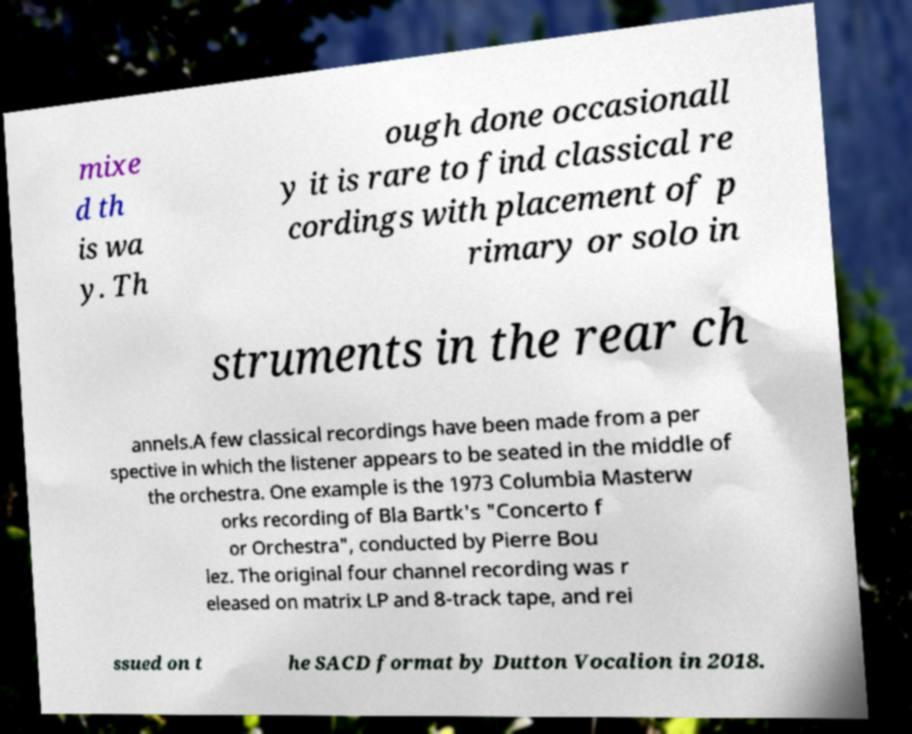Please read and relay the text visible in this image. What does it say? mixe d th is wa y. Th ough done occasionall y it is rare to find classical re cordings with placement of p rimary or solo in struments in the rear ch annels.A few classical recordings have been made from a per spective in which the listener appears to be seated in the middle of the orchestra. One example is the 1973 Columbia Masterw orks recording of Bla Bartk's "Concerto f or Orchestra", conducted by Pierre Bou lez. The original four channel recording was r eleased on matrix LP and 8-track tape, and rei ssued on t he SACD format by Dutton Vocalion in 2018. 